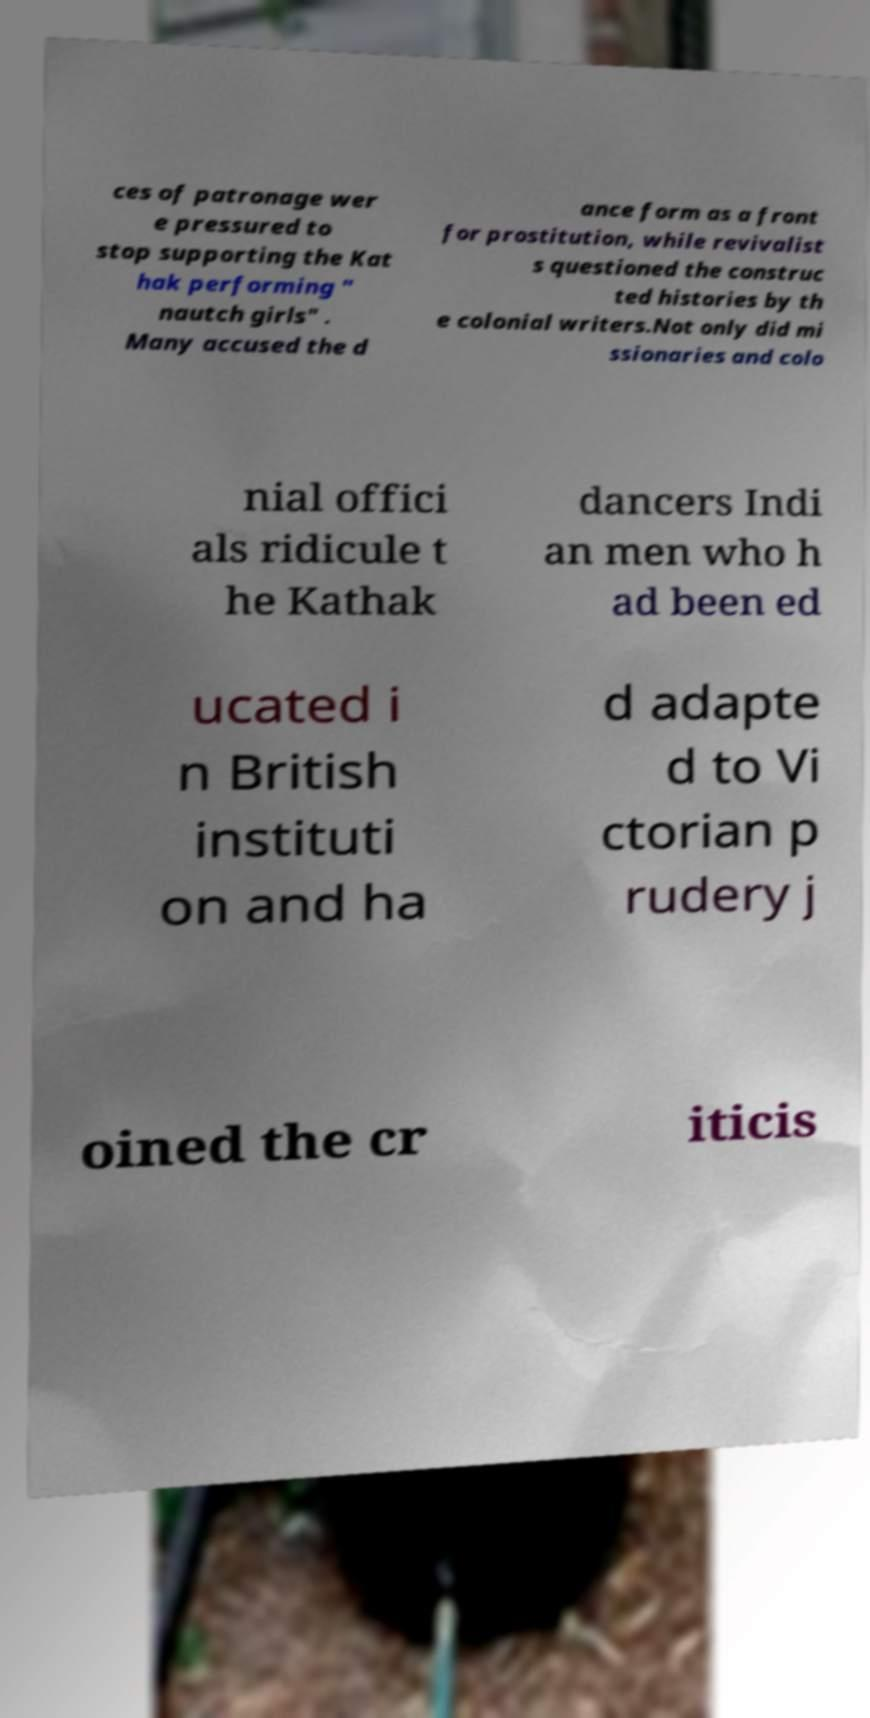Could you assist in decoding the text presented in this image and type it out clearly? ces of patronage wer e pressured to stop supporting the Kat hak performing " nautch girls" . Many accused the d ance form as a front for prostitution, while revivalist s questioned the construc ted histories by th e colonial writers.Not only did mi ssionaries and colo nial offici als ridicule t he Kathak dancers Indi an men who h ad been ed ucated i n British instituti on and ha d adapte d to Vi ctorian p rudery j oined the cr iticis 